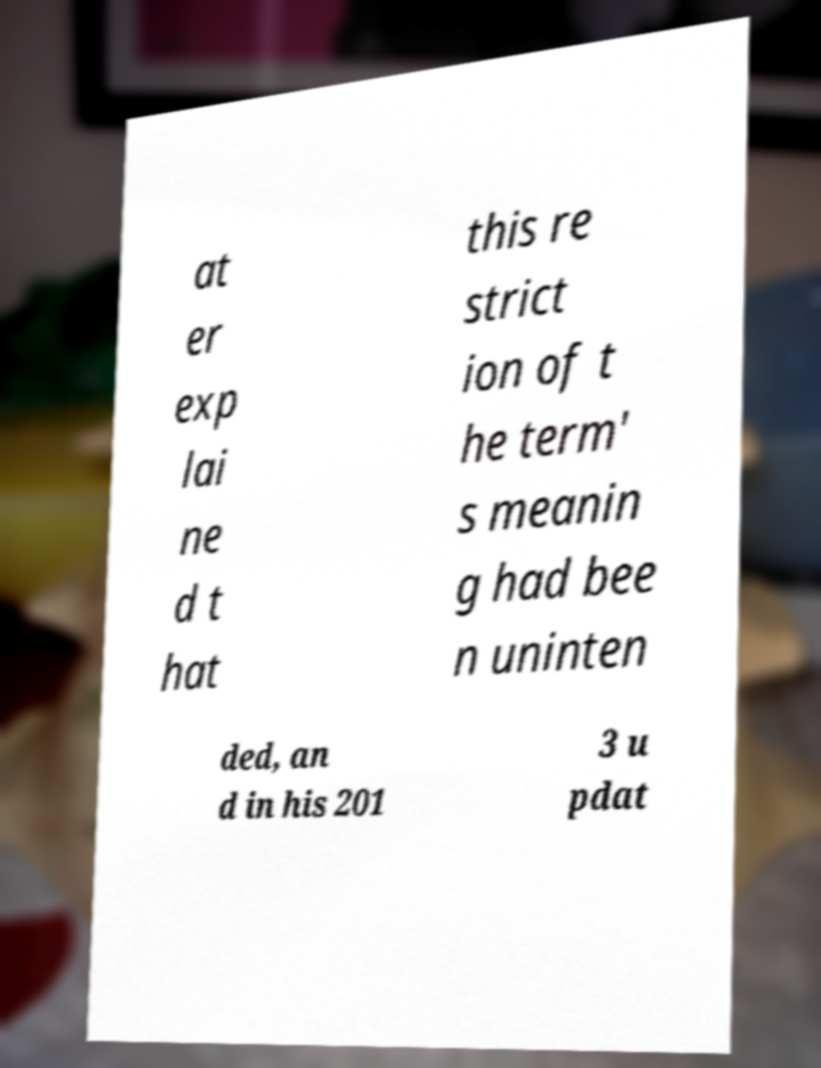Please read and relay the text visible in this image. What does it say? at er exp lai ne d t hat this re strict ion of t he term' s meanin g had bee n uninten ded, an d in his 201 3 u pdat 